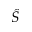<formula> <loc_0><loc_0><loc_500><loc_500>\hat { S }</formula> 